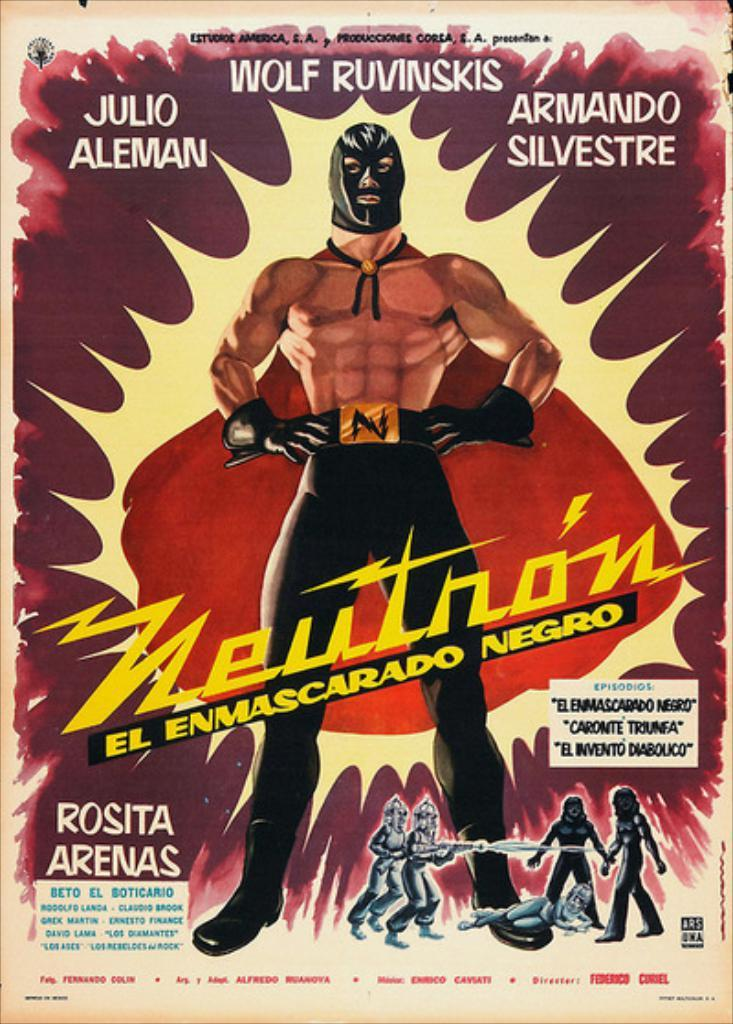What is the main subject of the image? There is a poster in the image. What is depicted on the poster? There is a man in the center of the poster, and there are people at the bottom of the poster. What else can be seen on the poster besides the images of people? There is text on the poster. What color is the cloth that the man is wearing in the image? There is no cloth visible in the image, as the man is depicted on a poster. How many people are laughing in the image? There is no indication of anyone laughing in the image, as it only shows a poster with people depicted on it. 